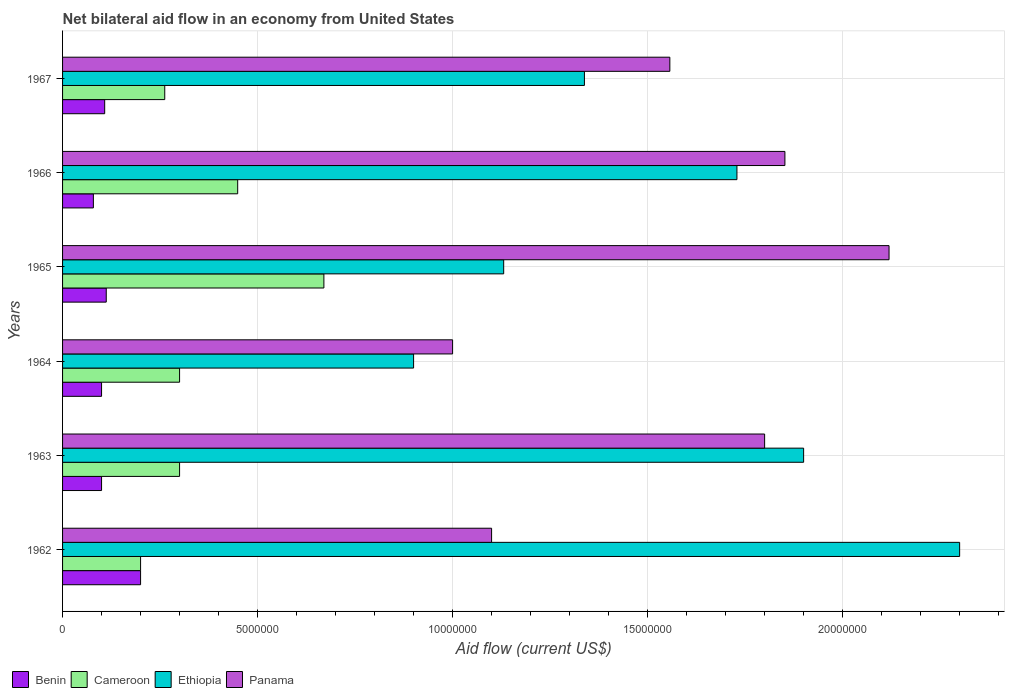Are the number of bars per tick equal to the number of legend labels?
Give a very brief answer. Yes. Are the number of bars on each tick of the Y-axis equal?
Your answer should be very brief. Yes. How many bars are there on the 5th tick from the top?
Offer a very short reply. 4. How many bars are there on the 2nd tick from the bottom?
Provide a succinct answer. 4. What is the label of the 1st group of bars from the top?
Make the answer very short. 1967. What is the net bilateral aid flow in Cameroon in 1967?
Keep it short and to the point. 2.62e+06. Across all years, what is the maximum net bilateral aid flow in Cameroon?
Offer a terse response. 6.70e+06. In which year was the net bilateral aid flow in Cameroon maximum?
Your answer should be very brief. 1965. In which year was the net bilateral aid flow in Ethiopia minimum?
Make the answer very short. 1964. What is the total net bilateral aid flow in Ethiopia in the graph?
Your answer should be compact. 9.30e+07. What is the difference between the net bilateral aid flow in Benin in 1964 and that in 1965?
Your response must be concise. -1.20e+05. What is the difference between the net bilateral aid flow in Cameroon in 1964 and the net bilateral aid flow in Panama in 1966?
Keep it short and to the point. -1.55e+07. What is the average net bilateral aid flow in Panama per year?
Offer a terse response. 1.57e+07. In the year 1964, what is the difference between the net bilateral aid flow in Panama and net bilateral aid flow in Ethiopia?
Offer a very short reply. 1.00e+06. What is the ratio of the net bilateral aid flow in Benin in 1963 to that in 1964?
Provide a succinct answer. 1. Is the difference between the net bilateral aid flow in Panama in 1963 and 1964 greater than the difference between the net bilateral aid flow in Ethiopia in 1963 and 1964?
Keep it short and to the point. No. What is the difference between the highest and the second highest net bilateral aid flow in Benin?
Offer a very short reply. 8.80e+05. What is the difference between the highest and the lowest net bilateral aid flow in Benin?
Give a very brief answer. 1.21e+06. Is the sum of the net bilateral aid flow in Panama in 1963 and 1965 greater than the maximum net bilateral aid flow in Benin across all years?
Your answer should be very brief. Yes. What does the 2nd bar from the top in 1965 represents?
Offer a terse response. Ethiopia. What does the 4th bar from the bottom in 1963 represents?
Offer a terse response. Panama. Are all the bars in the graph horizontal?
Make the answer very short. Yes. Are the values on the major ticks of X-axis written in scientific E-notation?
Ensure brevity in your answer.  No. Does the graph contain any zero values?
Your response must be concise. No. How are the legend labels stacked?
Your answer should be very brief. Horizontal. What is the title of the graph?
Ensure brevity in your answer.  Net bilateral aid flow in an economy from United States. Does "Denmark" appear as one of the legend labels in the graph?
Your response must be concise. No. What is the label or title of the X-axis?
Your answer should be compact. Aid flow (current US$). What is the Aid flow (current US$) in Benin in 1962?
Your response must be concise. 2.00e+06. What is the Aid flow (current US$) in Ethiopia in 1962?
Offer a terse response. 2.30e+07. What is the Aid flow (current US$) in Panama in 1962?
Give a very brief answer. 1.10e+07. What is the Aid flow (current US$) in Benin in 1963?
Provide a short and direct response. 1.00e+06. What is the Aid flow (current US$) in Cameroon in 1963?
Ensure brevity in your answer.  3.00e+06. What is the Aid flow (current US$) of Ethiopia in 1963?
Keep it short and to the point. 1.90e+07. What is the Aid flow (current US$) in Panama in 1963?
Your answer should be compact. 1.80e+07. What is the Aid flow (current US$) in Ethiopia in 1964?
Provide a short and direct response. 9.00e+06. What is the Aid flow (current US$) in Benin in 1965?
Make the answer very short. 1.12e+06. What is the Aid flow (current US$) in Cameroon in 1965?
Offer a terse response. 6.70e+06. What is the Aid flow (current US$) of Ethiopia in 1965?
Your response must be concise. 1.13e+07. What is the Aid flow (current US$) in Panama in 1965?
Provide a short and direct response. 2.12e+07. What is the Aid flow (current US$) of Benin in 1966?
Give a very brief answer. 7.90e+05. What is the Aid flow (current US$) of Cameroon in 1966?
Offer a very short reply. 4.49e+06. What is the Aid flow (current US$) of Ethiopia in 1966?
Your answer should be very brief. 1.73e+07. What is the Aid flow (current US$) of Panama in 1966?
Give a very brief answer. 1.85e+07. What is the Aid flow (current US$) in Benin in 1967?
Make the answer very short. 1.08e+06. What is the Aid flow (current US$) in Cameroon in 1967?
Offer a very short reply. 2.62e+06. What is the Aid flow (current US$) in Ethiopia in 1967?
Ensure brevity in your answer.  1.34e+07. What is the Aid flow (current US$) of Panama in 1967?
Ensure brevity in your answer.  1.56e+07. Across all years, what is the maximum Aid flow (current US$) in Cameroon?
Keep it short and to the point. 6.70e+06. Across all years, what is the maximum Aid flow (current US$) in Ethiopia?
Give a very brief answer. 2.30e+07. Across all years, what is the maximum Aid flow (current US$) in Panama?
Provide a succinct answer. 2.12e+07. Across all years, what is the minimum Aid flow (current US$) of Benin?
Provide a short and direct response. 7.90e+05. Across all years, what is the minimum Aid flow (current US$) of Cameroon?
Your answer should be very brief. 2.00e+06. Across all years, what is the minimum Aid flow (current US$) in Ethiopia?
Offer a very short reply. 9.00e+06. What is the total Aid flow (current US$) in Benin in the graph?
Keep it short and to the point. 6.99e+06. What is the total Aid flow (current US$) in Cameroon in the graph?
Make the answer very short. 2.18e+07. What is the total Aid flow (current US$) in Ethiopia in the graph?
Ensure brevity in your answer.  9.30e+07. What is the total Aid flow (current US$) of Panama in the graph?
Your response must be concise. 9.43e+07. What is the difference between the Aid flow (current US$) in Benin in 1962 and that in 1963?
Give a very brief answer. 1.00e+06. What is the difference between the Aid flow (current US$) in Cameroon in 1962 and that in 1963?
Give a very brief answer. -1.00e+06. What is the difference between the Aid flow (current US$) of Ethiopia in 1962 and that in 1963?
Provide a short and direct response. 4.00e+06. What is the difference between the Aid flow (current US$) in Panama in 1962 and that in 1963?
Ensure brevity in your answer.  -7.00e+06. What is the difference between the Aid flow (current US$) of Benin in 1962 and that in 1964?
Offer a very short reply. 1.00e+06. What is the difference between the Aid flow (current US$) in Cameroon in 1962 and that in 1964?
Make the answer very short. -1.00e+06. What is the difference between the Aid flow (current US$) in Ethiopia in 1962 and that in 1964?
Provide a short and direct response. 1.40e+07. What is the difference between the Aid flow (current US$) in Panama in 1962 and that in 1964?
Your response must be concise. 1.00e+06. What is the difference between the Aid flow (current US$) in Benin in 1962 and that in 1965?
Offer a terse response. 8.80e+05. What is the difference between the Aid flow (current US$) in Cameroon in 1962 and that in 1965?
Your answer should be compact. -4.70e+06. What is the difference between the Aid flow (current US$) of Ethiopia in 1962 and that in 1965?
Provide a succinct answer. 1.17e+07. What is the difference between the Aid flow (current US$) of Panama in 1962 and that in 1965?
Your answer should be very brief. -1.02e+07. What is the difference between the Aid flow (current US$) in Benin in 1962 and that in 1966?
Make the answer very short. 1.21e+06. What is the difference between the Aid flow (current US$) of Cameroon in 1962 and that in 1966?
Make the answer very short. -2.49e+06. What is the difference between the Aid flow (current US$) of Ethiopia in 1962 and that in 1966?
Ensure brevity in your answer.  5.71e+06. What is the difference between the Aid flow (current US$) in Panama in 1962 and that in 1966?
Offer a very short reply. -7.52e+06. What is the difference between the Aid flow (current US$) of Benin in 1962 and that in 1967?
Provide a succinct answer. 9.20e+05. What is the difference between the Aid flow (current US$) of Cameroon in 1962 and that in 1967?
Your answer should be very brief. -6.20e+05. What is the difference between the Aid flow (current US$) in Ethiopia in 1962 and that in 1967?
Keep it short and to the point. 9.62e+06. What is the difference between the Aid flow (current US$) of Panama in 1962 and that in 1967?
Your answer should be compact. -4.57e+06. What is the difference between the Aid flow (current US$) in Cameroon in 1963 and that in 1964?
Offer a terse response. 0. What is the difference between the Aid flow (current US$) in Ethiopia in 1963 and that in 1964?
Offer a terse response. 1.00e+07. What is the difference between the Aid flow (current US$) in Cameroon in 1963 and that in 1965?
Your answer should be very brief. -3.70e+06. What is the difference between the Aid flow (current US$) in Ethiopia in 1963 and that in 1965?
Provide a short and direct response. 7.69e+06. What is the difference between the Aid flow (current US$) in Panama in 1963 and that in 1965?
Offer a very short reply. -3.19e+06. What is the difference between the Aid flow (current US$) of Benin in 1963 and that in 1966?
Your answer should be compact. 2.10e+05. What is the difference between the Aid flow (current US$) in Cameroon in 1963 and that in 1966?
Offer a very short reply. -1.49e+06. What is the difference between the Aid flow (current US$) of Ethiopia in 1963 and that in 1966?
Make the answer very short. 1.71e+06. What is the difference between the Aid flow (current US$) in Panama in 1963 and that in 1966?
Make the answer very short. -5.20e+05. What is the difference between the Aid flow (current US$) of Benin in 1963 and that in 1967?
Make the answer very short. -8.00e+04. What is the difference between the Aid flow (current US$) in Ethiopia in 1963 and that in 1967?
Offer a very short reply. 5.62e+06. What is the difference between the Aid flow (current US$) in Panama in 1963 and that in 1967?
Make the answer very short. 2.43e+06. What is the difference between the Aid flow (current US$) in Cameroon in 1964 and that in 1965?
Your answer should be very brief. -3.70e+06. What is the difference between the Aid flow (current US$) of Ethiopia in 1964 and that in 1965?
Ensure brevity in your answer.  -2.31e+06. What is the difference between the Aid flow (current US$) of Panama in 1964 and that in 1965?
Give a very brief answer. -1.12e+07. What is the difference between the Aid flow (current US$) in Cameroon in 1964 and that in 1966?
Keep it short and to the point. -1.49e+06. What is the difference between the Aid flow (current US$) in Ethiopia in 1964 and that in 1966?
Give a very brief answer. -8.29e+06. What is the difference between the Aid flow (current US$) of Panama in 1964 and that in 1966?
Provide a succinct answer. -8.52e+06. What is the difference between the Aid flow (current US$) in Cameroon in 1964 and that in 1967?
Provide a short and direct response. 3.80e+05. What is the difference between the Aid flow (current US$) in Ethiopia in 1964 and that in 1967?
Your response must be concise. -4.38e+06. What is the difference between the Aid flow (current US$) in Panama in 1964 and that in 1967?
Your answer should be compact. -5.57e+06. What is the difference between the Aid flow (current US$) in Benin in 1965 and that in 1966?
Your answer should be very brief. 3.30e+05. What is the difference between the Aid flow (current US$) in Cameroon in 1965 and that in 1966?
Give a very brief answer. 2.21e+06. What is the difference between the Aid flow (current US$) of Ethiopia in 1965 and that in 1966?
Your answer should be compact. -5.98e+06. What is the difference between the Aid flow (current US$) in Panama in 1965 and that in 1966?
Offer a very short reply. 2.67e+06. What is the difference between the Aid flow (current US$) in Cameroon in 1965 and that in 1967?
Ensure brevity in your answer.  4.08e+06. What is the difference between the Aid flow (current US$) in Ethiopia in 1965 and that in 1967?
Ensure brevity in your answer.  -2.07e+06. What is the difference between the Aid flow (current US$) in Panama in 1965 and that in 1967?
Give a very brief answer. 5.62e+06. What is the difference between the Aid flow (current US$) of Cameroon in 1966 and that in 1967?
Your answer should be compact. 1.87e+06. What is the difference between the Aid flow (current US$) in Ethiopia in 1966 and that in 1967?
Make the answer very short. 3.91e+06. What is the difference between the Aid flow (current US$) of Panama in 1966 and that in 1967?
Your answer should be compact. 2.95e+06. What is the difference between the Aid flow (current US$) of Benin in 1962 and the Aid flow (current US$) of Cameroon in 1963?
Make the answer very short. -1.00e+06. What is the difference between the Aid flow (current US$) in Benin in 1962 and the Aid flow (current US$) in Ethiopia in 1963?
Give a very brief answer. -1.70e+07. What is the difference between the Aid flow (current US$) of Benin in 1962 and the Aid flow (current US$) of Panama in 1963?
Make the answer very short. -1.60e+07. What is the difference between the Aid flow (current US$) in Cameroon in 1962 and the Aid flow (current US$) in Ethiopia in 1963?
Your answer should be very brief. -1.70e+07. What is the difference between the Aid flow (current US$) in Cameroon in 1962 and the Aid flow (current US$) in Panama in 1963?
Ensure brevity in your answer.  -1.60e+07. What is the difference between the Aid flow (current US$) of Ethiopia in 1962 and the Aid flow (current US$) of Panama in 1963?
Offer a very short reply. 5.00e+06. What is the difference between the Aid flow (current US$) in Benin in 1962 and the Aid flow (current US$) in Cameroon in 1964?
Offer a terse response. -1.00e+06. What is the difference between the Aid flow (current US$) in Benin in 1962 and the Aid flow (current US$) in Ethiopia in 1964?
Keep it short and to the point. -7.00e+06. What is the difference between the Aid flow (current US$) of Benin in 1962 and the Aid flow (current US$) of Panama in 1964?
Offer a terse response. -8.00e+06. What is the difference between the Aid flow (current US$) of Cameroon in 1962 and the Aid flow (current US$) of Ethiopia in 1964?
Keep it short and to the point. -7.00e+06. What is the difference between the Aid flow (current US$) in Cameroon in 1962 and the Aid flow (current US$) in Panama in 1964?
Make the answer very short. -8.00e+06. What is the difference between the Aid flow (current US$) of Ethiopia in 1962 and the Aid flow (current US$) of Panama in 1964?
Your answer should be compact. 1.30e+07. What is the difference between the Aid flow (current US$) of Benin in 1962 and the Aid flow (current US$) of Cameroon in 1965?
Provide a short and direct response. -4.70e+06. What is the difference between the Aid flow (current US$) in Benin in 1962 and the Aid flow (current US$) in Ethiopia in 1965?
Offer a very short reply. -9.31e+06. What is the difference between the Aid flow (current US$) in Benin in 1962 and the Aid flow (current US$) in Panama in 1965?
Your answer should be compact. -1.92e+07. What is the difference between the Aid flow (current US$) of Cameroon in 1962 and the Aid flow (current US$) of Ethiopia in 1965?
Give a very brief answer. -9.31e+06. What is the difference between the Aid flow (current US$) of Cameroon in 1962 and the Aid flow (current US$) of Panama in 1965?
Your answer should be compact. -1.92e+07. What is the difference between the Aid flow (current US$) of Ethiopia in 1962 and the Aid flow (current US$) of Panama in 1965?
Provide a short and direct response. 1.81e+06. What is the difference between the Aid flow (current US$) of Benin in 1962 and the Aid flow (current US$) of Cameroon in 1966?
Give a very brief answer. -2.49e+06. What is the difference between the Aid flow (current US$) in Benin in 1962 and the Aid flow (current US$) in Ethiopia in 1966?
Your answer should be very brief. -1.53e+07. What is the difference between the Aid flow (current US$) of Benin in 1962 and the Aid flow (current US$) of Panama in 1966?
Keep it short and to the point. -1.65e+07. What is the difference between the Aid flow (current US$) of Cameroon in 1962 and the Aid flow (current US$) of Ethiopia in 1966?
Keep it short and to the point. -1.53e+07. What is the difference between the Aid flow (current US$) of Cameroon in 1962 and the Aid flow (current US$) of Panama in 1966?
Offer a very short reply. -1.65e+07. What is the difference between the Aid flow (current US$) in Ethiopia in 1962 and the Aid flow (current US$) in Panama in 1966?
Offer a terse response. 4.48e+06. What is the difference between the Aid flow (current US$) of Benin in 1962 and the Aid flow (current US$) of Cameroon in 1967?
Make the answer very short. -6.20e+05. What is the difference between the Aid flow (current US$) in Benin in 1962 and the Aid flow (current US$) in Ethiopia in 1967?
Give a very brief answer. -1.14e+07. What is the difference between the Aid flow (current US$) in Benin in 1962 and the Aid flow (current US$) in Panama in 1967?
Provide a succinct answer. -1.36e+07. What is the difference between the Aid flow (current US$) of Cameroon in 1962 and the Aid flow (current US$) of Ethiopia in 1967?
Provide a short and direct response. -1.14e+07. What is the difference between the Aid flow (current US$) of Cameroon in 1962 and the Aid flow (current US$) of Panama in 1967?
Provide a succinct answer. -1.36e+07. What is the difference between the Aid flow (current US$) of Ethiopia in 1962 and the Aid flow (current US$) of Panama in 1967?
Provide a succinct answer. 7.43e+06. What is the difference between the Aid flow (current US$) of Benin in 1963 and the Aid flow (current US$) of Ethiopia in 1964?
Keep it short and to the point. -8.00e+06. What is the difference between the Aid flow (current US$) in Benin in 1963 and the Aid flow (current US$) in Panama in 1964?
Your response must be concise. -9.00e+06. What is the difference between the Aid flow (current US$) in Cameroon in 1963 and the Aid flow (current US$) in Ethiopia in 1964?
Ensure brevity in your answer.  -6.00e+06. What is the difference between the Aid flow (current US$) in Cameroon in 1963 and the Aid flow (current US$) in Panama in 1964?
Provide a short and direct response. -7.00e+06. What is the difference between the Aid flow (current US$) of Ethiopia in 1963 and the Aid flow (current US$) of Panama in 1964?
Offer a terse response. 9.00e+06. What is the difference between the Aid flow (current US$) of Benin in 1963 and the Aid flow (current US$) of Cameroon in 1965?
Offer a terse response. -5.70e+06. What is the difference between the Aid flow (current US$) in Benin in 1963 and the Aid flow (current US$) in Ethiopia in 1965?
Provide a succinct answer. -1.03e+07. What is the difference between the Aid flow (current US$) in Benin in 1963 and the Aid flow (current US$) in Panama in 1965?
Your answer should be compact. -2.02e+07. What is the difference between the Aid flow (current US$) of Cameroon in 1963 and the Aid flow (current US$) of Ethiopia in 1965?
Your answer should be very brief. -8.31e+06. What is the difference between the Aid flow (current US$) of Cameroon in 1963 and the Aid flow (current US$) of Panama in 1965?
Your response must be concise. -1.82e+07. What is the difference between the Aid flow (current US$) of Ethiopia in 1963 and the Aid flow (current US$) of Panama in 1965?
Provide a succinct answer. -2.19e+06. What is the difference between the Aid flow (current US$) of Benin in 1963 and the Aid flow (current US$) of Cameroon in 1966?
Provide a succinct answer. -3.49e+06. What is the difference between the Aid flow (current US$) of Benin in 1963 and the Aid flow (current US$) of Ethiopia in 1966?
Offer a very short reply. -1.63e+07. What is the difference between the Aid flow (current US$) of Benin in 1963 and the Aid flow (current US$) of Panama in 1966?
Your answer should be compact. -1.75e+07. What is the difference between the Aid flow (current US$) of Cameroon in 1963 and the Aid flow (current US$) of Ethiopia in 1966?
Your answer should be compact. -1.43e+07. What is the difference between the Aid flow (current US$) of Cameroon in 1963 and the Aid flow (current US$) of Panama in 1966?
Give a very brief answer. -1.55e+07. What is the difference between the Aid flow (current US$) of Ethiopia in 1963 and the Aid flow (current US$) of Panama in 1966?
Keep it short and to the point. 4.80e+05. What is the difference between the Aid flow (current US$) of Benin in 1963 and the Aid flow (current US$) of Cameroon in 1967?
Make the answer very short. -1.62e+06. What is the difference between the Aid flow (current US$) in Benin in 1963 and the Aid flow (current US$) in Ethiopia in 1967?
Offer a very short reply. -1.24e+07. What is the difference between the Aid flow (current US$) in Benin in 1963 and the Aid flow (current US$) in Panama in 1967?
Make the answer very short. -1.46e+07. What is the difference between the Aid flow (current US$) of Cameroon in 1963 and the Aid flow (current US$) of Ethiopia in 1967?
Offer a very short reply. -1.04e+07. What is the difference between the Aid flow (current US$) in Cameroon in 1963 and the Aid flow (current US$) in Panama in 1967?
Your response must be concise. -1.26e+07. What is the difference between the Aid flow (current US$) in Ethiopia in 1963 and the Aid flow (current US$) in Panama in 1967?
Make the answer very short. 3.43e+06. What is the difference between the Aid flow (current US$) of Benin in 1964 and the Aid flow (current US$) of Cameroon in 1965?
Offer a terse response. -5.70e+06. What is the difference between the Aid flow (current US$) in Benin in 1964 and the Aid flow (current US$) in Ethiopia in 1965?
Your response must be concise. -1.03e+07. What is the difference between the Aid flow (current US$) in Benin in 1964 and the Aid flow (current US$) in Panama in 1965?
Your answer should be very brief. -2.02e+07. What is the difference between the Aid flow (current US$) of Cameroon in 1964 and the Aid flow (current US$) of Ethiopia in 1965?
Keep it short and to the point. -8.31e+06. What is the difference between the Aid flow (current US$) in Cameroon in 1964 and the Aid flow (current US$) in Panama in 1965?
Ensure brevity in your answer.  -1.82e+07. What is the difference between the Aid flow (current US$) in Ethiopia in 1964 and the Aid flow (current US$) in Panama in 1965?
Give a very brief answer. -1.22e+07. What is the difference between the Aid flow (current US$) of Benin in 1964 and the Aid flow (current US$) of Cameroon in 1966?
Offer a very short reply. -3.49e+06. What is the difference between the Aid flow (current US$) of Benin in 1964 and the Aid flow (current US$) of Ethiopia in 1966?
Your answer should be very brief. -1.63e+07. What is the difference between the Aid flow (current US$) in Benin in 1964 and the Aid flow (current US$) in Panama in 1966?
Make the answer very short. -1.75e+07. What is the difference between the Aid flow (current US$) in Cameroon in 1964 and the Aid flow (current US$) in Ethiopia in 1966?
Provide a succinct answer. -1.43e+07. What is the difference between the Aid flow (current US$) of Cameroon in 1964 and the Aid flow (current US$) of Panama in 1966?
Ensure brevity in your answer.  -1.55e+07. What is the difference between the Aid flow (current US$) of Ethiopia in 1964 and the Aid flow (current US$) of Panama in 1966?
Keep it short and to the point. -9.52e+06. What is the difference between the Aid flow (current US$) of Benin in 1964 and the Aid flow (current US$) of Cameroon in 1967?
Your response must be concise. -1.62e+06. What is the difference between the Aid flow (current US$) in Benin in 1964 and the Aid flow (current US$) in Ethiopia in 1967?
Offer a terse response. -1.24e+07. What is the difference between the Aid flow (current US$) in Benin in 1964 and the Aid flow (current US$) in Panama in 1967?
Provide a succinct answer. -1.46e+07. What is the difference between the Aid flow (current US$) in Cameroon in 1964 and the Aid flow (current US$) in Ethiopia in 1967?
Provide a short and direct response. -1.04e+07. What is the difference between the Aid flow (current US$) in Cameroon in 1964 and the Aid flow (current US$) in Panama in 1967?
Provide a succinct answer. -1.26e+07. What is the difference between the Aid flow (current US$) in Ethiopia in 1964 and the Aid flow (current US$) in Panama in 1967?
Offer a terse response. -6.57e+06. What is the difference between the Aid flow (current US$) in Benin in 1965 and the Aid flow (current US$) in Cameroon in 1966?
Make the answer very short. -3.37e+06. What is the difference between the Aid flow (current US$) of Benin in 1965 and the Aid flow (current US$) of Ethiopia in 1966?
Keep it short and to the point. -1.62e+07. What is the difference between the Aid flow (current US$) of Benin in 1965 and the Aid flow (current US$) of Panama in 1966?
Your response must be concise. -1.74e+07. What is the difference between the Aid flow (current US$) in Cameroon in 1965 and the Aid flow (current US$) in Ethiopia in 1966?
Keep it short and to the point. -1.06e+07. What is the difference between the Aid flow (current US$) of Cameroon in 1965 and the Aid flow (current US$) of Panama in 1966?
Give a very brief answer. -1.18e+07. What is the difference between the Aid flow (current US$) of Ethiopia in 1965 and the Aid flow (current US$) of Panama in 1966?
Your answer should be compact. -7.21e+06. What is the difference between the Aid flow (current US$) in Benin in 1965 and the Aid flow (current US$) in Cameroon in 1967?
Provide a short and direct response. -1.50e+06. What is the difference between the Aid flow (current US$) in Benin in 1965 and the Aid flow (current US$) in Ethiopia in 1967?
Your response must be concise. -1.23e+07. What is the difference between the Aid flow (current US$) in Benin in 1965 and the Aid flow (current US$) in Panama in 1967?
Make the answer very short. -1.44e+07. What is the difference between the Aid flow (current US$) in Cameroon in 1965 and the Aid flow (current US$) in Ethiopia in 1967?
Provide a succinct answer. -6.68e+06. What is the difference between the Aid flow (current US$) in Cameroon in 1965 and the Aid flow (current US$) in Panama in 1967?
Ensure brevity in your answer.  -8.87e+06. What is the difference between the Aid flow (current US$) of Ethiopia in 1965 and the Aid flow (current US$) of Panama in 1967?
Ensure brevity in your answer.  -4.26e+06. What is the difference between the Aid flow (current US$) in Benin in 1966 and the Aid flow (current US$) in Cameroon in 1967?
Keep it short and to the point. -1.83e+06. What is the difference between the Aid flow (current US$) in Benin in 1966 and the Aid flow (current US$) in Ethiopia in 1967?
Your answer should be compact. -1.26e+07. What is the difference between the Aid flow (current US$) in Benin in 1966 and the Aid flow (current US$) in Panama in 1967?
Give a very brief answer. -1.48e+07. What is the difference between the Aid flow (current US$) in Cameroon in 1966 and the Aid flow (current US$) in Ethiopia in 1967?
Your answer should be compact. -8.89e+06. What is the difference between the Aid flow (current US$) of Cameroon in 1966 and the Aid flow (current US$) of Panama in 1967?
Provide a succinct answer. -1.11e+07. What is the difference between the Aid flow (current US$) of Ethiopia in 1966 and the Aid flow (current US$) of Panama in 1967?
Your answer should be compact. 1.72e+06. What is the average Aid flow (current US$) of Benin per year?
Ensure brevity in your answer.  1.16e+06. What is the average Aid flow (current US$) of Cameroon per year?
Provide a short and direct response. 3.64e+06. What is the average Aid flow (current US$) in Ethiopia per year?
Provide a succinct answer. 1.55e+07. What is the average Aid flow (current US$) in Panama per year?
Provide a succinct answer. 1.57e+07. In the year 1962, what is the difference between the Aid flow (current US$) of Benin and Aid flow (current US$) of Cameroon?
Offer a very short reply. 0. In the year 1962, what is the difference between the Aid flow (current US$) of Benin and Aid flow (current US$) of Ethiopia?
Ensure brevity in your answer.  -2.10e+07. In the year 1962, what is the difference between the Aid flow (current US$) of Benin and Aid flow (current US$) of Panama?
Ensure brevity in your answer.  -9.00e+06. In the year 1962, what is the difference between the Aid flow (current US$) in Cameroon and Aid flow (current US$) in Ethiopia?
Provide a succinct answer. -2.10e+07. In the year 1962, what is the difference between the Aid flow (current US$) of Cameroon and Aid flow (current US$) of Panama?
Offer a terse response. -9.00e+06. In the year 1963, what is the difference between the Aid flow (current US$) of Benin and Aid flow (current US$) of Cameroon?
Offer a terse response. -2.00e+06. In the year 1963, what is the difference between the Aid flow (current US$) of Benin and Aid flow (current US$) of Ethiopia?
Your response must be concise. -1.80e+07. In the year 1963, what is the difference between the Aid flow (current US$) of Benin and Aid flow (current US$) of Panama?
Provide a succinct answer. -1.70e+07. In the year 1963, what is the difference between the Aid flow (current US$) in Cameroon and Aid flow (current US$) in Ethiopia?
Offer a very short reply. -1.60e+07. In the year 1963, what is the difference between the Aid flow (current US$) of Cameroon and Aid flow (current US$) of Panama?
Provide a succinct answer. -1.50e+07. In the year 1963, what is the difference between the Aid flow (current US$) in Ethiopia and Aid flow (current US$) in Panama?
Your answer should be very brief. 1.00e+06. In the year 1964, what is the difference between the Aid flow (current US$) in Benin and Aid flow (current US$) in Ethiopia?
Ensure brevity in your answer.  -8.00e+06. In the year 1964, what is the difference between the Aid flow (current US$) of Benin and Aid flow (current US$) of Panama?
Your answer should be very brief. -9.00e+06. In the year 1964, what is the difference between the Aid flow (current US$) in Cameroon and Aid flow (current US$) in Ethiopia?
Give a very brief answer. -6.00e+06. In the year 1964, what is the difference between the Aid flow (current US$) of Cameroon and Aid flow (current US$) of Panama?
Offer a terse response. -7.00e+06. In the year 1965, what is the difference between the Aid flow (current US$) in Benin and Aid flow (current US$) in Cameroon?
Offer a terse response. -5.58e+06. In the year 1965, what is the difference between the Aid flow (current US$) in Benin and Aid flow (current US$) in Ethiopia?
Ensure brevity in your answer.  -1.02e+07. In the year 1965, what is the difference between the Aid flow (current US$) in Benin and Aid flow (current US$) in Panama?
Provide a short and direct response. -2.01e+07. In the year 1965, what is the difference between the Aid flow (current US$) in Cameroon and Aid flow (current US$) in Ethiopia?
Give a very brief answer. -4.61e+06. In the year 1965, what is the difference between the Aid flow (current US$) in Cameroon and Aid flow (current US$) in Panama?
Provide a short and direct response. -1.45e+07. In the year 1965, what is the difference between the Aid flow (current US$) of Ethiopia and Aid flow (current US$) of Panama?
Provide a short and direct response. -9.88e+06. In the year 1966, what is the difference between the Aid flow (current US$) of Benin and Aid flow (current US$) of Cameroon?
Offer a terse response. -3.70e+06. In the year 1966, what is the difference between the Aid flow (current US$) in Benin and Aid flow (current US$) in Ethiopia?
Your answer should be very brief. -1.65e+07. In the year 1966, what is the difference between the Aid flow (current US$) of Benin and Aid flow (current US$) of Panama?
Your response must be concise. -1.77e+07. In the year 1966, what is the difference between the Aid flow (current US$) in Cameroon and Aid flow (current US$) in Ethiopia?
Ensure brevity in your answer.  -1.28e+07. In the year 1966, what is the difference between the Aid flow (current US$) in Cameroon and Aid flow (current US$) in Panama?
Give a very brief answer. -1.40e+07. In the year 1966, what is the difference between the Aid flow (current US$) of Ethiopia and Aid flow (current US$) of Panama?
Give a very brief answer. -1.23e+06. In the year 1967, what is the difference between the Aid flow (current US$) of Benin and Aid flow (current US$) of Cameroon?
Provide a succinct answer. -1.54e+06. In the year 1967, what is the difference between the Aid flow (current US$) in Benin and Aid flow (current US$) in Ethiopia?
Give a very brief answer. -1.23e+07. In the year 1967, what is the difference between the Aid flow (current US$) in Benin and Aid flow (current US$) in Panama?
Ensure brevity in your answer.  -1.45e+07. In the year 1967, what is the difference between the Aid flow (current US$) of Cameroon and Aid flow (current US$) of Ethiopia?
Your response must be concise. -1.08e+07. In the year 1967, what is the difference between the Aid flow (current US$) of Cameroon and Aid flow (current US$) of Panama?
Provide a succinct answer. -1.30e+07. In the year 1967, what is the difference between the Aid flow (current US$) in Ethiopia and Aid flow (current US$) in Panama?
Offer a very short reply. -2.19e+06. What is the ratio of the Aid flow (current US$) in Cameroon in 1962 to that in 1963?
Your answer should be compact. 0.67. What is the ratio of the Aid flow (current US$) of Ethiopia in 1962 to that in 1963?
Make the answer very short. 1.21. What is the ratio of the Aid flow (current US$) of Panama in 1962 to that in 1963?
Keep it short and to the point. 0.61. What is the ratio of the Aid flow (current US$) of Cameroon in 1962 to that in 1964?
Your answer should be compact. 0.67. What is the ratio of the Aid flow (current US$) in Ethiopia in 1962 to that in 1964?
Your answer should be compact. 2.56. What is the ratio of the Aid flow (current US$) of Benin in 1962 to that in 1965?
Provide a short and direct response. 1.79. What is the ratio of the Aid flow (current US$) in Cameroon in 1962 to that in 1965?
Offer a terse response. 0.3. What is the ratio of the Aid flow (current US$) in Ethiopia in 1962 to that in 1965?
Make the answer very short. 2.03. What is the ratio of the Aid flow (current US$) of Panama in 1962 to that in 1965?
Give a very brief answer. 0.52. What is the ratio of the Aid flow (current US$) in Benin in 1962 to that in 1966?
Give a very brief answer. 2.53. What is the ratio of the Aid flow (current US$) of Cameroon in 1962 to that in 1966?
Offer a terse response. 0.45. What is the ratio of the Aid flow (current US$) in Ethiopia in 1962 to that in 1966?
Provide a short and direct response. 1.33. What is the ratio of the Aid flow (current US$) in Panama in 1962 to that in 1966?
Make the answer very short. 0.59. What is the ratio of the Aid flow (current US$) of Benin in 1962 to that in 1967?
Ensure brevity in your answer.  1.85. What is the ratio of the Aid flow (current US$) in Cameroon in 1962 to that in 1967?
Your response must be concise. 0.76. What is the ratio of the Aid flow (current US$) in Ethiopia in 1962 to that in 1967?
Keep it short and to the point. 1.72. What is the ratio of the Aid flow (current US$) of Panama in 1962 to that in 1967?
Keep it short and to the point. 0.71. What is the ratio of the Aid flow (current US$) of Ethiopia in 1963 to that in 1964?
Provide a succinct answer. 2.11. What is the ratio of the Aid flow (current US$) in Benin in 1963 to that in 1965?
Provide a succinct answer. 0.89. What is the ratio of the Aid flow (current US$) of Cameroon in 1963 to that in 1965?
Your answer should be compact. 0.45. What is the ratio of the Aid flow (current US$) of Ethiopia in 1963 to that in 1965?
Offer a terse response. 1.68. What is the ratio of the Aid flow (current US$) of Panama in 1963 to that in 1965?
Provide a succinct answer. 0.85. What is the ratio of the Aid flow (current US$) in Benin in 1963 to that in 1966?
Provide a succinct answer. 1.27. What is the ratio of the Aid flow (current US$) of Cameroon in 1963 to that in 1966?
Make the answer very short. 0.67. What is the ratio of the Aid flow (current US$) of Ethiopia in 1963 to that in 1966?
Give a very brief answer. 1.1. What is the ratio of the Aid flow (current US$) of Panama in 1963 to that in 1966?
Offer a very short reply. 0.97. What is the ratio of the Aid flow (current US$) of Benin in 1963 to that in 1967?
Your answer should be compact. 0.93. What is the ratio of the Aid flow (current US$) in Cameroon in 1963 to that in 1967?
Give a very brief answer. 1.15. What is the ratio of the Aid flow (current US$) in Ethiopia in 1963 to that in 1967?
Ensure brevity in your answer.  1.42. What is the ratio of the Aid flow (current US$) in Panama in 1963 to that in 1967?
Provide a succinct answer. 1.16. What is the ratio of the Aid flow (current US$) in Benin in 1964 to that in 1965?
Ensure brevity in your answer.  0.89. What is the ratio of the Aid flow (current US$) in Cameroon in 1964 to that in 1965?
Your answer should be very brief. 0.45. What is the ratio of the Aid flow (current US$) of Ethiopia in 1964 to that in 1965?
Your response must be concise. 0.8. What is the ratio of the Aid flow (current US$) in Panama in 1964 to that in 1965?
Offer a very short reply. 0.47. What is the ratio of the Aid flow (current US$) in Benin in 1964 to that in 1966?
Offer a terse response. 1.27. What is the ratio of the Aid flow (current US$) in Cameroon in 1964 to that in 1966?
Your answer should be very brief. 0.67. What is the ratio of the Aid flow (current US$) in Ethiopia in 1964 to that in 1966?
Offer a terse response. 0.52. What is the ratio of the Aid flow (current US$) of Panama in 1964 to that in 1966?
Ensure brevity in your answer.  0.54. What is the ratio of the Aid flow (current US$) of Benin in 1964 to that in 1967?
Give a very brief answer. 0.93. What is the ratio of the Aid flow (current US$) of Cameroon in 1964 to that in 1967?
Give a very brief answer. 1.15. What is the ratio of the Aid flow (current US$) in Ethiopia in 1964 to that in 1967?
Give a very brief answer. 0.67. What is the ratio of the Aid flow (current US$) in Panama in 1964 to that in 1967?
Provide a short and direct response. 0.64. What is the ratio of the Aid flow (current US$) of Benin in 1965 to that in 1966?
Provide a succinct answer. 1.42. What is the ratio of the Aid flow (current US$) in Cameroon in 1965 to that in 1966?
Provide a succinct answer. 1.49. What is the ratio of the Aid flow (current US$) of Ethiopia in 1965 to that in 1966?
Provide a short and direct response. 0.65. What is the ratio of the Aid flow (current US$) in Panama in 1965 to that in 1966?
Give a very brief answer. 1.14. What is the ratio of the Aid flow (current US$) in Benin in 1965 to that in 1967?
Provide a short and direct response. 1.04. What is the ratio of the Aid flow (current US$) in Cameroon in 1965 to that in 1967?
Give a very brief answer. 2.56. What is the ratio of the Aid flow (current US$) of Ethiopia in 1965 to that in 1967?
Make the answer very short. 0.85. What is the ratio of the Aid flow (current US$) in Panama in 1965 to that in 1967?
Offer a very short reply. 1.36. What is the ratio of the Aid flow (current US$) in Benin in 1966 to that in 1967?
Ensure brevity in your answer.  0.73. What is the ratio of the Aid flow (current US$) in Cameroon in 1966 to that in 1967?
Give a very brief answer. 1.71. What is the ratio of the Aid flow (current US$) in Ethiopia in 1966 to that in 1967?
Keep it short and to the point. 1.29. What is the ratio of the Aid flow (current US$) of Panama in 1966 to that in 1967?
Offer a terse response. 1.19. What is the difference between the highest and the second highest Aid flow (current US$) in Benin?
Provide a succinct answer. 8.80e+05. What is the difference between the highest and the second highest Aid flow (current US$) of Cameroon?
Provide a short and direct response. 2.21e+06. What is the difference between the highest and the second highest Aid flow (current US$) of Panama?
Your answer should be compact. 2.67e+06. What is the difference between the highest and the lowest Aid flow (current US$) of Benin?
Provide a succinct answer. 1.21e+06. What is the difference between the highest and the lowest Aid flow (current US$) in Cameroon?
Your response must be concise. 4.70e+06. What is the difference between the highest and the lowest Aid flow (current US$) of Ethiopia?
Your response must be concise. 1.40e+07. What is the difference between the highest and the lowest Aid flow (current US$) of Panama?
Your response must be concise. 1.12e+07. 